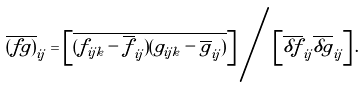<formula> <loc_0><loc_0><loc_500><loc_500>\overline { ( f g ) } _ { i j } = \left [ \overline { ( f _ { i j k } - \overline { f } _ { i j } ) ( g _ { i j k } - \overline { g } _ { i j } ) } \right ] \Big / \left [ \overline { \delta f } _ { i j } \overline { \delta g } _ { i j } \right ] .</formula> 